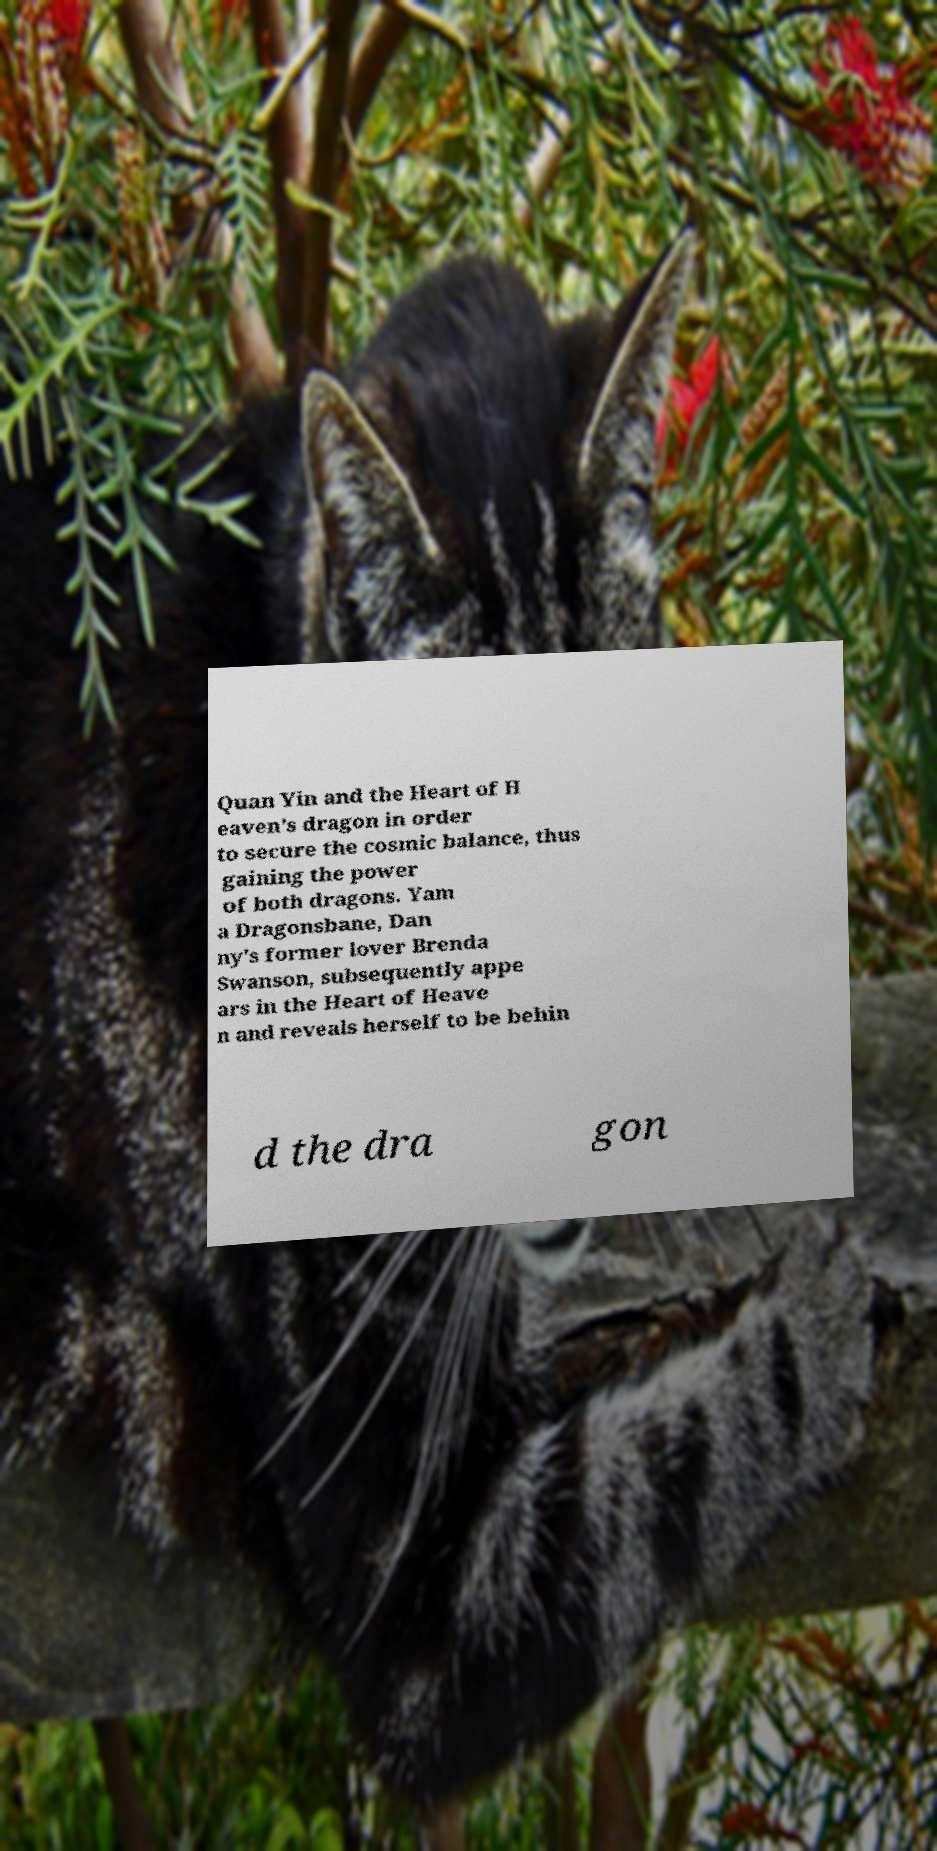Please identify and transcribe the text found in this image. Quan Yin and the Heart of H eaven's dragon in order to secure the cosmic balance, thus gaining the power of both dragons. Yam a Dragonsbane, Dan ny's former lover Brenda Swanson, subsequently appe ars in the Heart of Heave n and reveals herself to be behin d the dra gon 